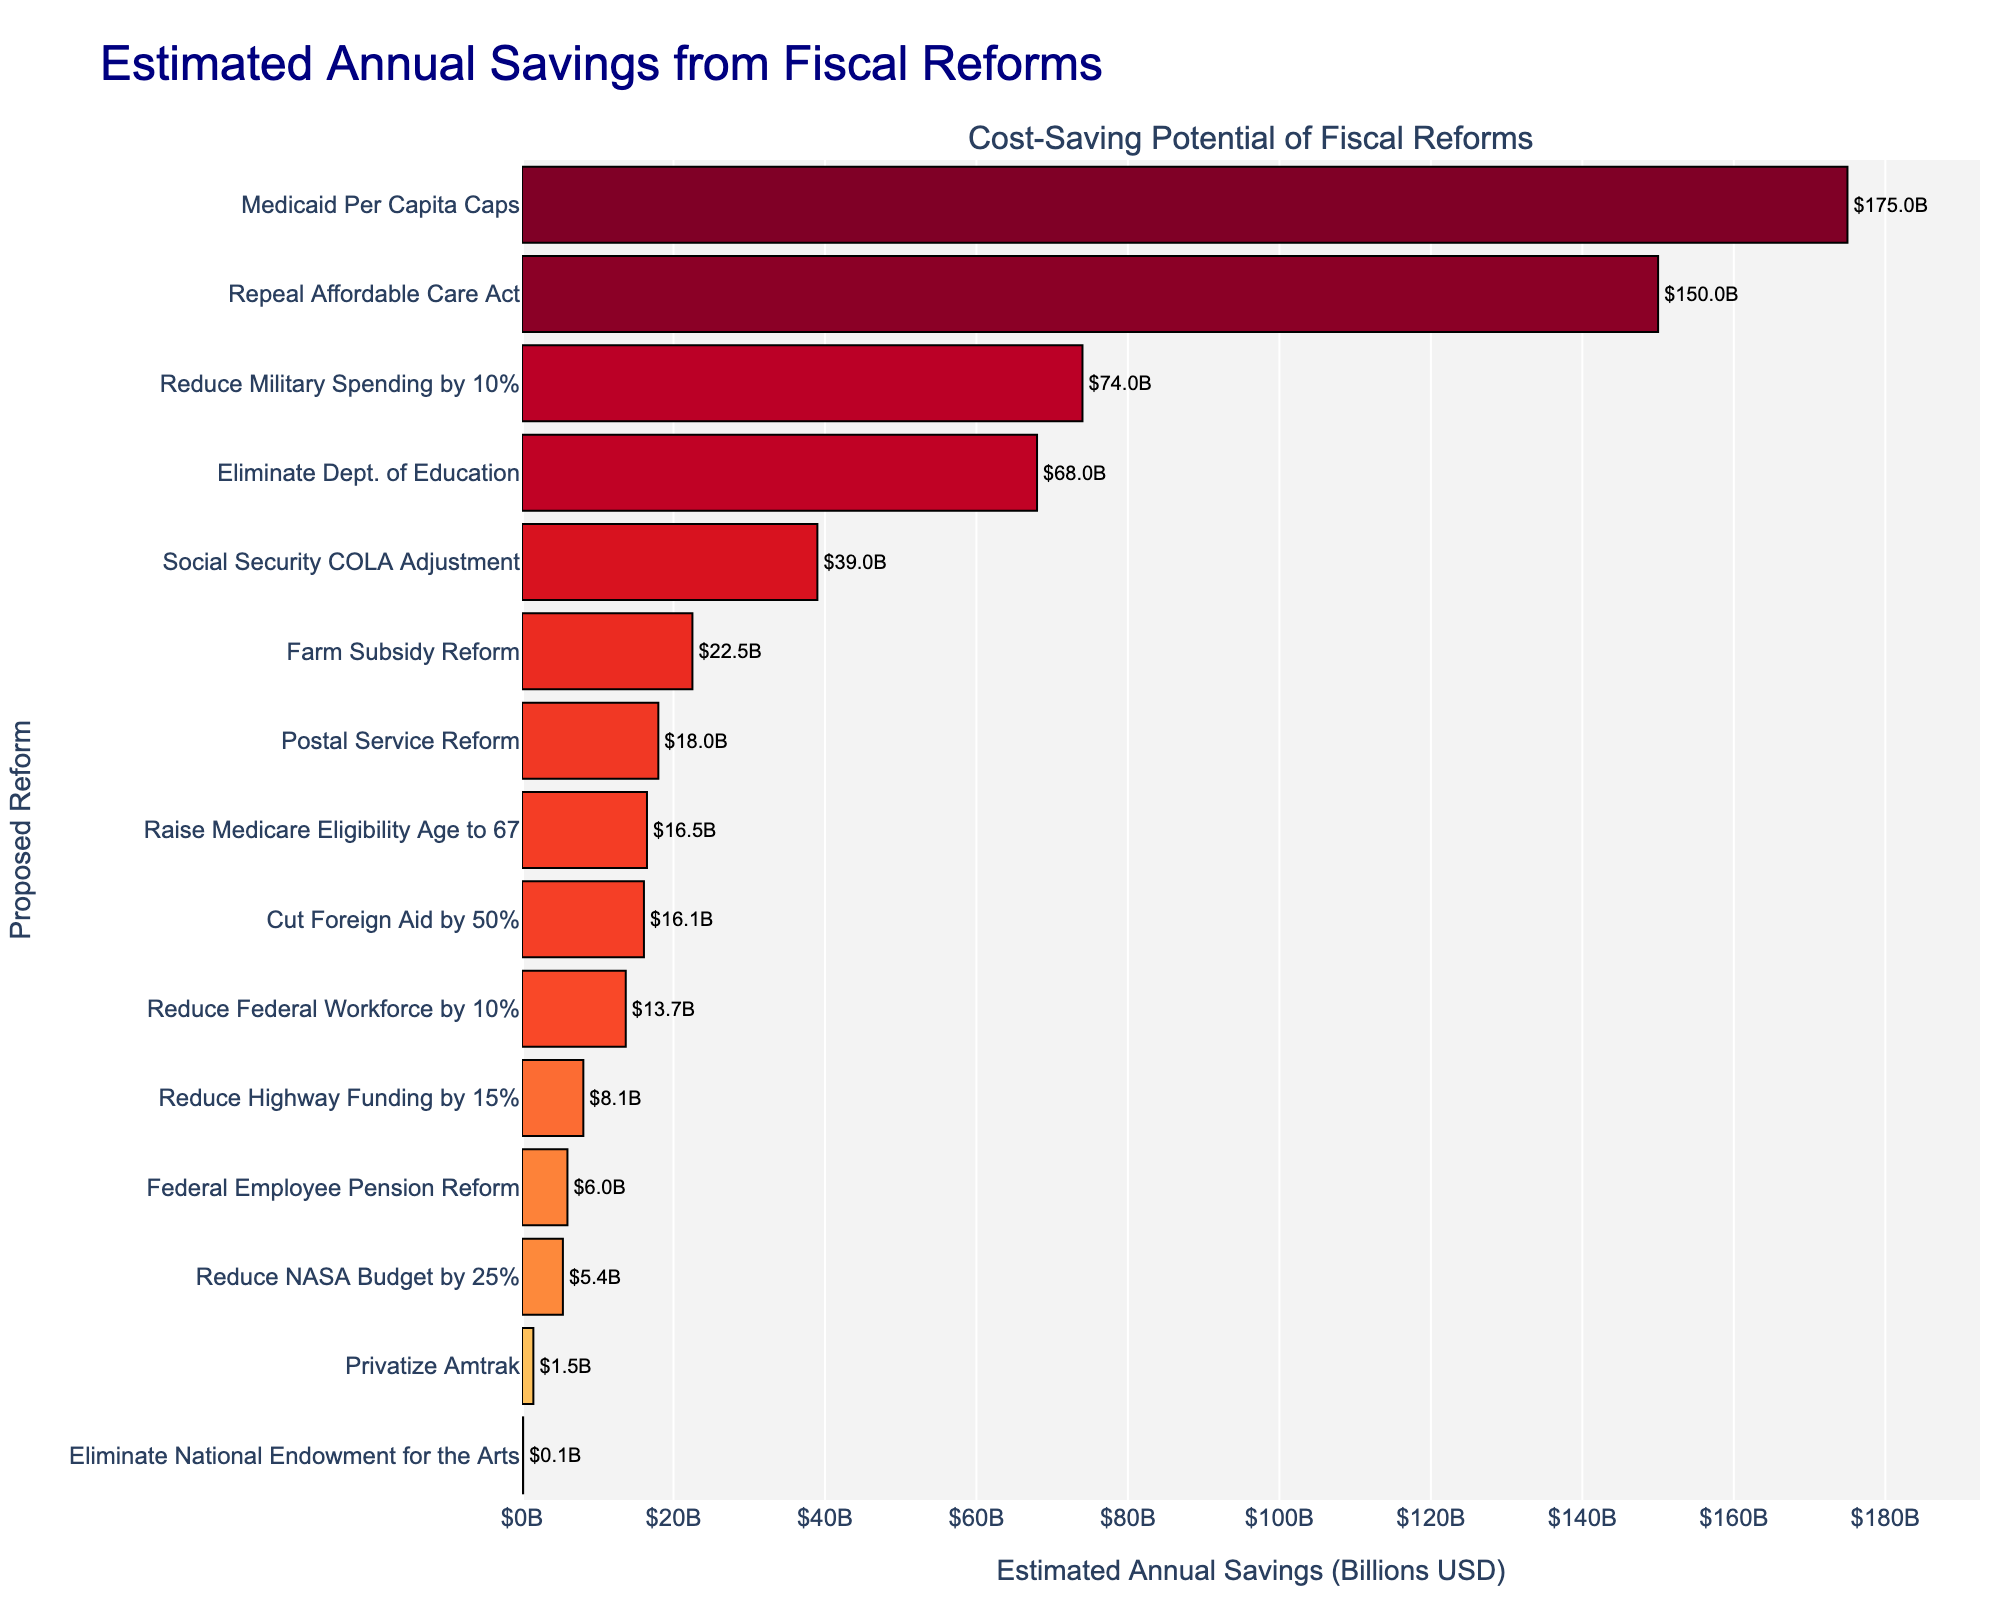Which fiscal reform has the highest estimated annual savings? The bar for Medicaid Per Capita Caps is the longest, indicating it has the highest estimated savings.
Answer: Medicaid Per Capita Caps What's the combined annual savings from eliminating the Department of Education and from Social Security COLA Adjustment? The savings from eliminating the Department of Education is $68.0 billion and from Social Security COLA Adjustment is $39.0 billion. Adding these together gives $68.0B + $39.0B = $107.0B.
Answer: $107.0B How does the savings from reducing federal workforce by 10% compare to the savings from reducing NASA budget by 25%? The bar for reducing the federal workforce by 10% shows $13.7 billion in savings, which is significantly longer than the bar for reducing the NASA budget by 25%, which shows $5.4 billion in savings.
Answer: Greater What is the median estimated annual savings among all proposed reforms? To find the median, we need to order the savings values and find the middle value. Listing the savings in ascending order: $0.15B, $1.5B, $5.4B, $6.0B, $8.1B, $13.7B, $16.1B, $16.5B, $18.0B, $22.5B, $39.0B, $68.0B, $74.0B, $150.0B, $175.0B. The median is the 8th value in this ordered list: $16.5B.
Answer: $16.5B Which fiscal reform is represented by the shortest bar? The bar representing $0.15 billion, the shortest one in the chart, corresponds to eliminating the National Endowment for the Arts.
Answer: Eliminate National Endowment for the Arts How much more savings does repealing the Affordable Care Act generate compared to farm subsidy reform? Repealing the Affordable Care Act generates $150.0 billion in savings, while farm subsidy reform generates $22.5 billion. The difference is $150.0B - $22.5B = $127.5B.
Answer: $127.5B Is the annual savings from postal service reform higher or lower than reducing highway funding by 15%? The savings from postal service reform is $18.0 billion, and from reducing highway funding by 15% is $8.1 billion. The savings from postal service reform is higher.
Answer: Higher What is the visual difference between the bars for reducing military spending by 10% and cutting foreign aid by 50%? The bar for reducing military spending by 10% is visually longer and more intense in color compared to the bar for cutting foreign aid by 50%, indicating higher savings.
Answer: Longer and more intense What do the different colors in the bars indicate? The colors of the bars represent the logarithm of the estimated annual savings, indicating different ranges of savings visually, with more intense colors often representing higher savings.
Answer: Varying ranges of savings 